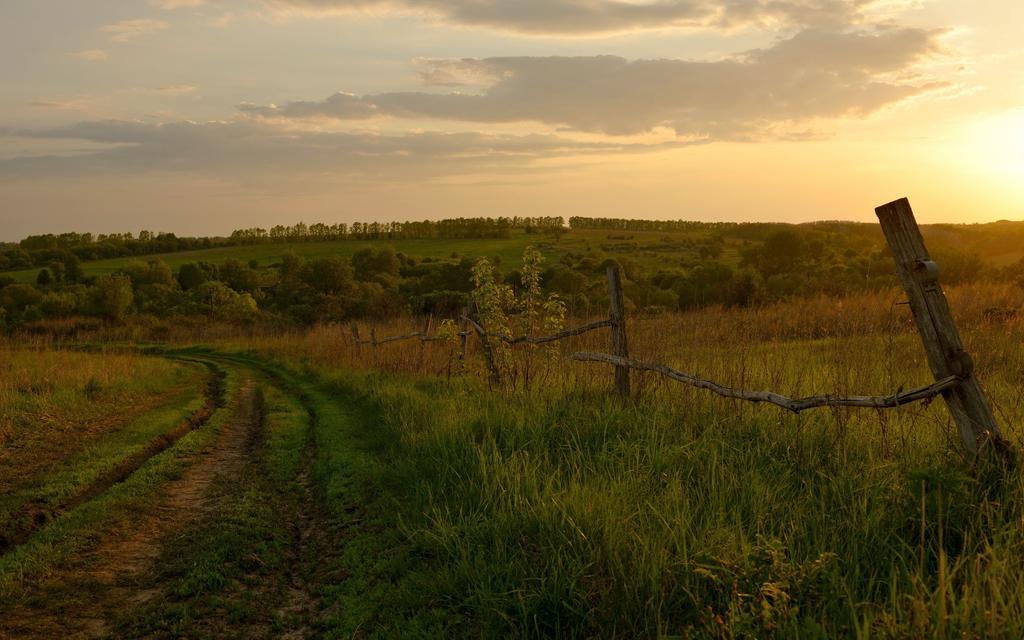In one or two sentences, can you explain what this image depicts? In the center of the image we can see trees, grass, plants, fencing are there. At the bottom of the image ground is there. At the top of the image clouds are present in the sky. 